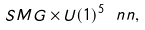<formula> <loc_0><loc_0><loc_500><loc_500>S M G \times U ( 1 ) ^ { 5 } \ n n ,</formula> 